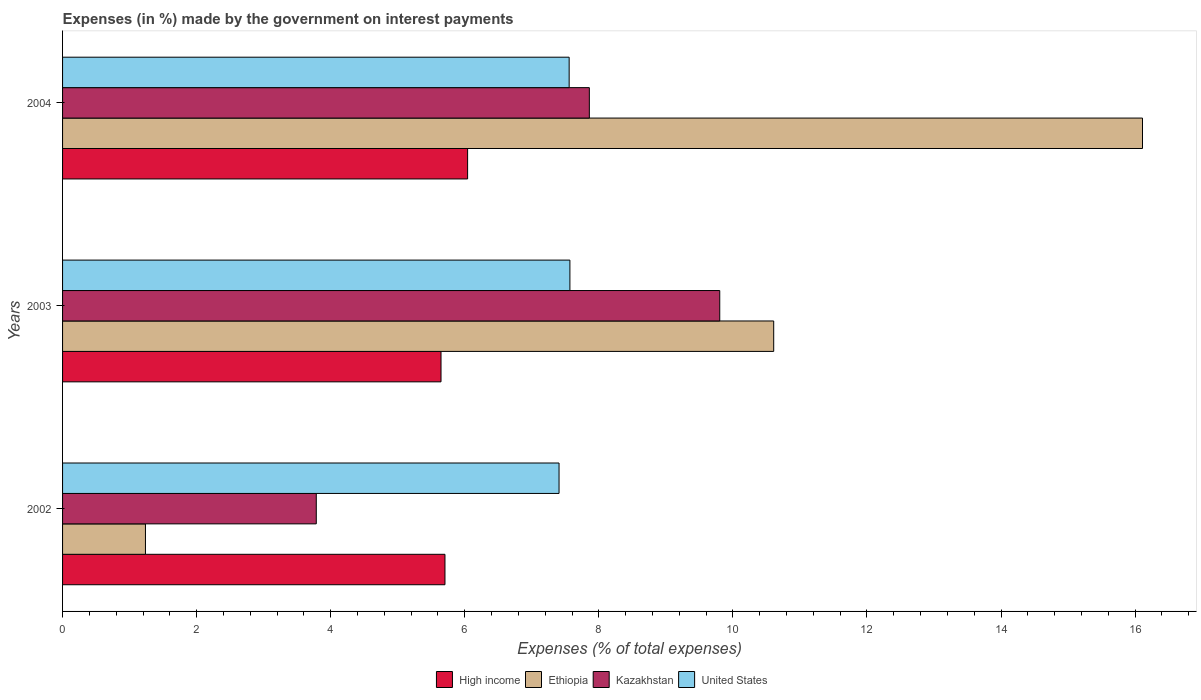How many different coloured bars are there?
Your response must be concise. 4. Are the number of bars per tick equal to the number of legend labels?
Offer a very short reply. Yes. Are the number of bars on each tick of the Y-axis equal?
Keep it short and to the point. Yes. How many bars are there on the 2nd tick from the bottom?
Provide a short and direct response. 4. What is the label of the 3rd group of bars from the top?
Your response must be concise. 2002. What is the percentage of expenses made by the government on interest payments in Ethiopia in 2004?
Provide a succinct answer. 16.11. Across all years, what is the maximum percentage of expenses made by the government on interest payments in High income?
Offer a very short reply. 6.04. Across all years, what is the minimum percentage of expenses made by the government on interest payments in United States?
Make the answer very short. 7.41. In which year was the percentage of expenses made by the government on interest payments in Kazakhstan maximum?
Ensure brevity in your answer.  2003. In which year was the percentage of expenses made by the government on interest payments in United States minimum?
Your response must be concise. 2002. What is the total percentage of expenses made by the government on interest payments in Ethiopia in the graph?
Ensure brevity in your answer.  27.95. What is the difference between the percentage of expenses made by the government on interest payments in Ethiopia in 2003 and that in 2004?
Give a very brief answer. -5.5. What is the difference between the percentage of expenses made by the government on interest payments in Ethiopia in 2004 and the percentage of expenses made by the government on interest payments in Kazakhstan in 2002?
Your answer should be very brief. 12.33. What is the average percentage of expenses made by the government on interest payments in Ethiopia per year?
Make the answer very short. 9.32. In the year 2002, what is the difference between the percentage of expenses made by the government on interest payments in United States and percentage of expenses made by the government on interest payments in Kazakhstan?
Provide a succinct answer. 3.62. In how many years, is the percentage of expenses made by the government on interest payments in Kazakhstan greater than 15.6 %?
Offer a terse response. 0. What is the ratio of the percentage of expenses made by the government on interest payments in United States in 2003 to that in 2004?
Your answer should be very brief. 1. Is the difference between the percentage of expenses made by the government on interest payments in United States in 2003 and 2004 greater than the difference between the percentage of expenses made by the government on interest payments in Kazakhstan in 2003 and 2004?
Offer a very short reply. No. What is the difference between the highest and the second highest percentage of expenses made by the government on interest payments in Ethiopia?
Your answer should be very brief. 5.5. What is the difference between the highest and the lowest percentage of expenses made by the government on interest payments in Kazakhstan?
Offer a very short reply. 6.02. Is it the case that in every year, the sum of the percentage of expenses made by the government on interest payments in United States and percentage of expenses made by the government on interest payments in High income is greater than the sum of percentage of expenses made by the government on interest payments in Kazakhstan and percentage of expenses made by the government on interest payments in Ethiopia?
Your response must be concise. No. What does the 1st bar from the top in 2003 represents?
Your response must be concise. United States. What does the 3rd bar from the bottom in 2004 represents?
Offer a terse response. Kazakhstan. Is it the case that in every year, the sum of the percentage of expenses made by the government on interest payments in Kazakhstan and percentage of expenses made by the government on interest payments in Ethiopia is greater than the percentage of expenses made by the government on interest payments in High income?
Your answer should be very brief. No. How many bars are there?
Your answer should be compact. 12. How many years are there in the graph?
Offer a very short reply. 3. Are the values on the major ticks of X-axis written in scientific E-notation?
Ensure brevity in your answer.  No. Does the graph contain any zero values?
Provide a short and direct response. No. How many legend labels are there?
Provide a succinct answer. 4. What is the title of the graph?
Keep it short and to the point. Expenses (in %) made by the government on interest payments. What is the label or title of the X-axis?
Offer a very short reply. Expenses (% of total expenses). What is the Expenses (% of total expenses) in High income in 2002?
Offer a terse response. 5.7. What is the Expenses (% of total expenses) in Ethiopia in 2002?
Make the answer very short. 1.24. What is the Expenses (% of total expenses) in Kazakhstan in 2002?
Offer a terse response. 3.78. What is the Expenses (% of total expenses) of United States in 2002?
Offer a very short reply. 7.41. What is the Expenses (% of total expenses) of High income in 2003?
Provide a short and direct response. 5.65. What is the Expenses (% of total expenses) in Ethiopia in 2003?
Your answer should be very brief. 10.61. What is the Expenses (% of total expenses) in Kazakhstan in 2003?
Give a very brief answer. 9.8. What is the Expenses (% of total expenses) of United States in 2003?
Your answer should be very brief. 7.57. What is the Expenses (% of total expenses) in High income in 2004?
Provide a succinct answer. 6.04. What is the Expenses (% of total expenses) in Ethiopia in 2004?
Offer a very short reply. 16.11. What is the Expenses (% of total expenses) of Kazakhstan in 2004?
Provide a succinct answer. 7.86. What is the Expenses (% of total expenses) in United States in 2004?
Ensure brevity in your answer.  7.56. Across all years, what is the maximum Expenses (% of total expenses) of High income?
Your answer should be compact. 6.04. Across all years, what is the maximum Expenses (% of total expenses) in Ethiopia?
Ensure brevity in your answer.  16.11. Across all years, what is the maximum Expenses (% of total expenses) of Kazakhstan?
Give a very brief answer. 9.8. Across all years, what is the maximum Expenses (% of total expenses) of United States?
Provide a short and direct response. 7.57. Across all years, what is the minimum Expenses (% of total expenses) in High income?
Provide a short and direct response. 5.65. Across all years, what is the minimum Expenses (% of total expenses) of Ethiopia?
Offer a very short reply. 1.24. Across all years, what is the minimum Expenses (% of total expenses) in Kazakhstan?
Give a very brief answer. 3.78. Across all years, what is the minimum Expenses (% of total expenses) in United States?
Offer a terse response. 7.41. What is the total Expenses (% of total expenses) in High income in the graph?
Offer a very short reply. 17.39. What is the total Expenses (% of total expenses) of Ethiopia in the graph?
Offer a very short reply. 27.95. What is the total Expenses (% of total expenses) in Kazakhstan in the graph?
Offer a terse response. 21.45. What is the total Expenses (% of total expenses) of United States in the graph?
Make the answer very short. 22.53. What is the difference between the Expenses (% of total expenses) in High income in 2002 and that in 2003?
Your answer should be very brief. 0.06. What is the difference between the Expenses (% of total expenses) of Ethiopia in 2002 and that in 2003?
Give a very brief answer. -9.37. What is the difference between the Expenses (% of total expenses) of Kazakhstan in 2002 and that in 2003?
Your answer should be compact. -6.02. What is the difference between the Expenses (% of total expenses) of United States in 2002 and that in 2003?
Ensure brevity in your answer.  -0.16. What is the difference between the Expenses (% of total expenses) in High income in 2002 and that in 2004?
Ensure brevity in your answer.  -0.34. What is the difference between the Expenses (% of total expenses) of Ethiopia in 2002 and that in 2004?
Your response must be concise. -14.87. What is the difference between the Expenses (% of total expenses) of Kazakhstan in 2002 and that in 2004?
Offer a very short reply. -4.07. What is the difference between the Expenses (% of total expenses) in United States in 2002 and that in 2004?
Your answer should be very brief. -0.15. What is the difference between the Expenses (% of total expenses) in High income in 2003 and that in 2004?
Make the answer very short. -0.4. What is the difference between the Expenses (% of total expenses) in Ethiopia in 2003 and that in 2004?
Offer a very short reply. -5.5. What is the difference between the Expenses (% of total expenses) in Kazakhstan in 2003 and that in 2004?
Give a very brief answer. 1.95. What is the difference between the Expenses (% of total expenses) in United States in 2003 and that in 2004?
Your answer should be compact. 0.01. What is the difference between the Expenses (% of total expenses) of High income in 2002 and the Expenses (% of total expenses) of Ethiopia in 2003?
Give a very brief answer. -4.9. What is the difference between the Expenses (% of total expenses) in High income in 2002 and the Expenses (% of total expenses) in Kazakhstan in 2003?
Provide a short and direct response. -4.1. What is the difference between the Expenses (% of total expenses) of High income in 2002 and the Expenses (% of total expenses) of United States in 2003?
Offer a terse response. -1.86. What is the difference between the Expenses (% of total expenses) of Ethiopia in 2002 and the Expenses (% of total expenses) of Kazakhstan in 2003?
Give a very brief answer. -8.57. What is the difference between the Expenses (% of total expenses) in Ethiopia in 2002 and the Expenses (% of total expenses) in United States in 2003?
Your response must be concise. -6.33. What is the difference between the Expenses (% of total expenses) in Kazakhstan in 2002 and the Expenses (% of total expenses) in United States in 2003?
Give a very brief answer. -3.78. What is the difference between the Expenses (% of total expenses) in High income in 2002 and the Expenses (% of total expenses) in Ethiopia in 2004?
Your answer should be very brief. -10.41. What is the difference between the Expenses (% of total expenses) of High income in 2002 and the Expenses (% of total expenses) of Kazakhstan in 2004?
Offer a very short reply. -2.15. What is the difference between the Expenses (% of total expenses) in High income in 2002 and the Expenses (% of total expenses) in United States in 2004?
Make the answer very short. -1.85. What is the difference between the Expenses (% of total expenses) in Ethiopia in 2002 and the Expenses (% of total expenses) in Kazakhstan in 2004?
Make the answer very short. -6.62. What is the difference between the Expenses (% of total expenses) of Ethiopia in 2002 and the Expenses (% of total expenses) of United States in 2004?
Ensure brevity in your answer.  -6.32. What is the difference between the Expenses (% of total expenses) of Kazakhstan in 2002 and the Expenses (% of total expenses) of United States in 2004?
Ensure brevity in your answer.  -3.77. What is the difference between the Expenses (% of total expenses) in High income in 2003 and the Expenses (% of total expenses) in Ethiopia in 2004?
Your answer should be compact. -10.46. What is the difference between the Expenses (% of total expenses) in High income in 2003 and the Expenses (% of total expenses) in Kazakhstan in 2004?
Provide a short and direct response. -2.21. What is the difference between the Expenses (% of total expenses) of High income in 2003 and the Expenses (% of total expenses) of United States in 2004?
Your answer should be compact. -1.91. What is the difference between the Expenses (% of total expenses) in Ethiopia in 2003 and the Expenses (% of total expenses) in Kazakhstan in 2004?
Provide a succinct answer. 2.75. What is the difference between the Expenses (% of total expenses) of Ethiopia in 2003 and the Expenses (% of total expenses) of United States in 2004?
Your answer should be very brief. 3.05. What is the difference between the Expenses (% of total expenses) in Kazakhstan in 2003 and the Expenses (% of total expenses) in United States in 2004?
Provide a succinct answer. 2.25. What is the average Expenses (% of total expenses) in High income per year?
Give a very brief answer. 5.8. What is the average Expenses (% of total expenses) of Ethiopia per year?
Provide a succinct answer. 9.32. What is the average Expenses (% of total expenses) in Kazakhstan per year?
Give a very brief answer. 7.15. What is the average Expenses (% of total expenses) of United States per year?
Give a very brief answer. 7.51. In the year 2002, what is the difference between the Expenses (% of total expenses) of High income and Expenses (% of total expenses) of Ethiopia?
Ensure brevity in your answer.  4.47. In the year 2002, what is the difference between the Expenses (% of total expenses) of High income and Expenses (% of total expenses) of Kazakhstan?
Offer a very short reply. 1.92. In the year 2002, what is the difference between the Expenses (% of total expenses) in High income and Expenses (% of total expenses) in United States?
Your response must be concise. -1.7. In the year 2002, what is the difference between the Expenses (% of total expenses) in Ethiopia and Expenses (% of total expenses) in Kazakhstan?
Provide a short and direct response. -2.55. In the year 2002, what is the difference between the Expenses (% of total expenses) in Ethiopia and Expenses (% of total expenses) in United States?
Provide a short and direct response. -6.17. In the year 2002, what is the difference between the Expenses (% of total expenses) in Kazakhstan and Expenses (% of total expenses) in United States?
Provide a short and direct response. -3.62. In the year 2003, what is the difference between the Expenses (% of total expenses) of High income and Expenses (% of total expenses) of Ethiopia?
Your response must be concise. -4.96. In the year 2003, what is the difference between the Expenses (% of total expenses) of High income and Expenses (% of total expenses) of Kazakhstan?
Your response must be concise. -4.16. In the year 2003, what is the difference between the Expenses (% of total expenses) of High income and Expenses (% of total expenses) of United States?
Ensure brevity in your answer.  -1.92. In the year 2003, what is the difference between the Expenses (% of total expenses) of Ethiopia and Expenses (% of total expenses) of Kazakhstan?
Your response must be concise. 0.8. In the year 2003, what is the difference between the Expenses (% of total expenses) in Ethiopia and Expenses (% of total expenses) in United States?
Your answer should be very brief. 3.04. In the year 2003, what is the difference between the Expenses (% of total expenses) of Kazakhstan and Expenses (% of total expenses) of United States?
Your answer should be very brief. 2.24. In the year 2004, what is the difference between the Expenses (% of total expenses) of High income and Expenses (% of total expenses) of Ethiopia?
Your answer should be compact. -10.07. In the year 2004, what is the difference between the Expenses (% of total expenses) of High income and Expenses (% of total expenses) of Kazakhstan?
Your answer should be very brief. -1.82. In the year 2004, what is the difference between the Expenses (% of total expenses) in High income and Expenses (% of total expenses) in United States?
Your answer should be very brief. -1.51. In the year 2004, what is the difference between the Expenses (% of total expenses) of Ethiopia and Expenses (% of total expenses) of Kazakhstan?
Your answer should be compact. 8.25. In the year 2004, what is the difference between the Expenses (% of total expenses) in Ethiopia and Expenses (% of total expenses) in United States?
Your answer should be compact. 8.55. In the year 2004, what is the difference between the Expenses (% of total expenses) of Kazakhstan and Expenses (% of total expenses) of United States?
Your response must be concise. 0.3. What is the ratio of the Expenses (% of total expenses) in High income in 2002 to that in 2003?
Your answer should be compact. 1.01. What is the ratio of the Expenses (% of total expenses) of Ethiopia in 2002 to that in 2003?
Provide a succinct answer. 0.12. What is the ratio of the Expenses (% of total expenses) of Kazakhstan in 2002 to that in 2003?
Ensure brevity in your answer.  0.39. What is the ratio of the Expenses (% of total expenses) in United States in 2002 to that in 2003?
Ensure brevity in your answer.  0.98. What is the ratio of the Expenses (% of total expenses) in High income in 2002 to that in 2004?
Provide a short and direct response. 0.94. What is the ratio of the Expenses (% of total expenses) of Ethiopia in 2002 to that in 2004?
Offer a terse response. 0.08. What is the ratio of the Expenses (% of total expenses) in Kazakhstan in 2002 to that in 2004?
Offer a very short reply. 0.48. What is the ratio of the Expenses (% of total expenses) of United States in 2002 to that in 2004?
Your response must be concise. 0.98. What is the ratio of the Expenses (% of total expenses) of High income in 2003 to that in 2004?
Keep it short and to the point. 0.93. What is the ratio of the Expenses (% of total expenses) in Ethiopia in 2003 to that in 2004?
Make the answer very short. 0.66. What is the ratio of the Expenses (% of total expenses) of Kazakhstan in 2003 to that in 2004?
Offer a very short reply. 1.25. What is the ratio of the Expenses (% of total expenses) in United States in 2003 to that in 2004?
Your answer should be compact. 1. What is the difference between the highest and the second highest Expenses (% of total expenses) of High income?
Make the answer very short. 0.34. What is the difference between the highest and the second highest Expenses (% of total expenses) in Ethiopia?
Provide a short and direct response. 5.5. What is the difference between the highest and the second highest Expenses (% of total expenses) in Kazakhstan?
Offer a very short reply. 1.95. What is the difference between the highest and the second highest Expenses (% of total expenses) in United States?
Provide a succinct answer. 0.01. What is the difference between the highest and the lowest Expenses (% of total expenses) of High income?
Keep it short and to the point. 0.4. What is the difference between the highest and the lowest Expenses (% of total expenses) of Ethiopia?
Offer a very short reply. 14.87. What is the difference between the highest and the lowest Expenses (% of total expenses) of Kazakhstan?
Your answer should be very brief. 6.02. What is the difference between the highest and the lowest Expenses (% of total expenses) in United States?
Provide a succinct answer. 0.16. 